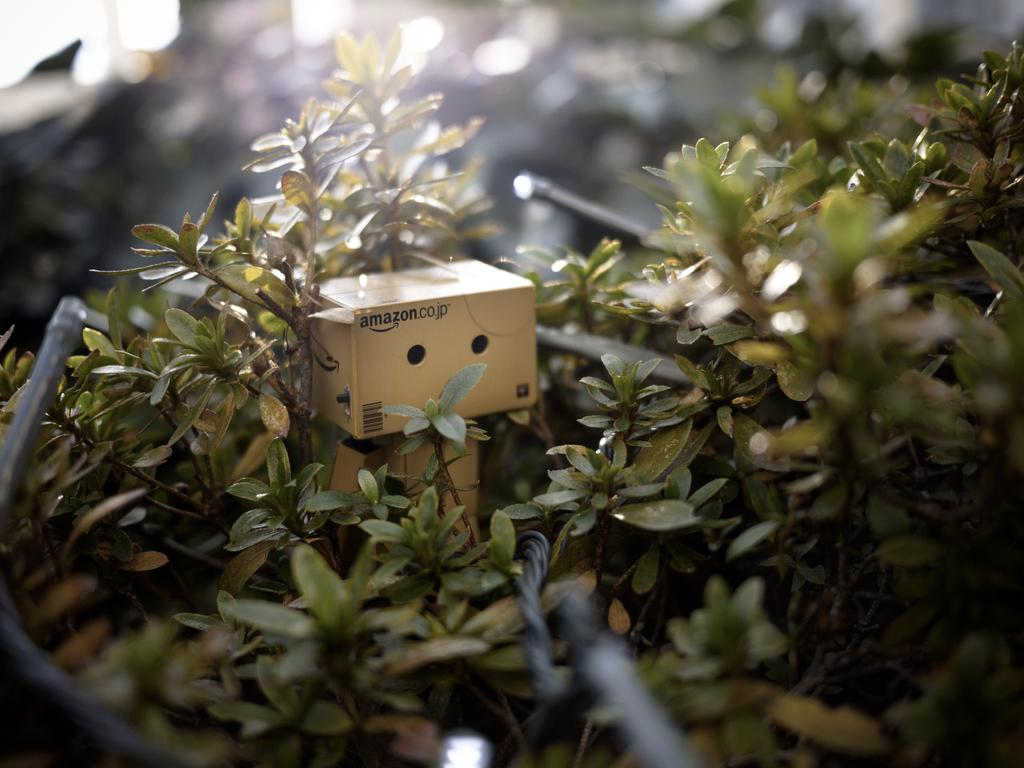What shape is the metal object in the image? The metal object in the image is rectangular shaped. Where is the metal object located in relation to the plants? The metal object is present in the middle of the plants. What type of map can be seen in the image? There is no map present in the image; it features a rectangular shaped metal object in the middle of plants. How does the metal object express hate in the image? The metal object does not express hate in the image; it is an inanimate object and cannot express emotions. 